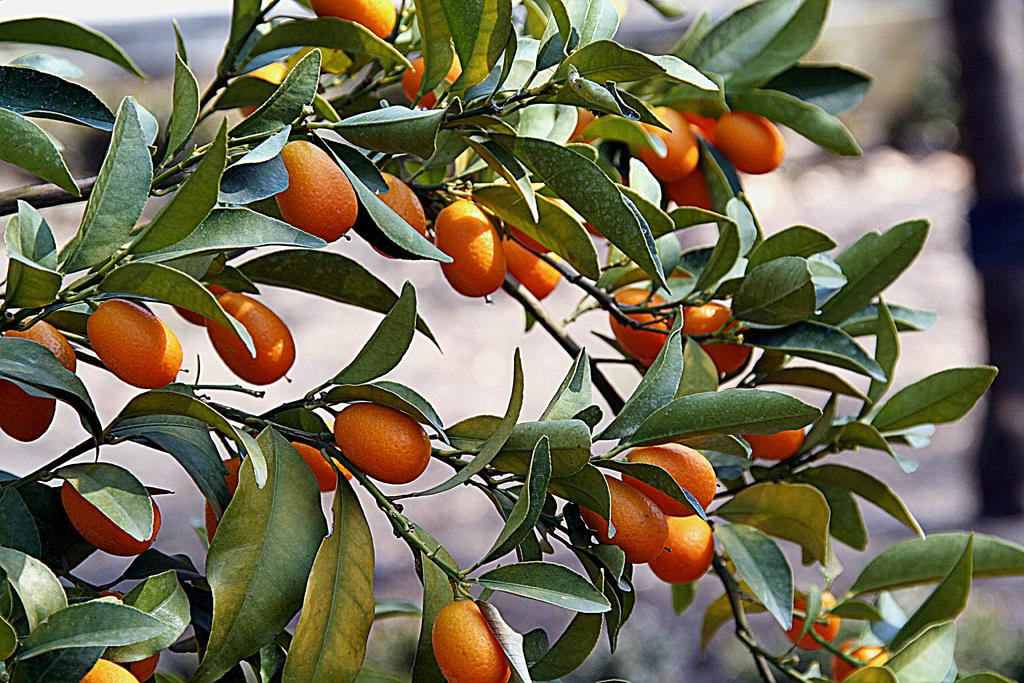What type of plant is in the image? There is a Kumquat plant in the image. Can you describe the background of the image? The background of the image is blurred. What is the temperature of the Kumquat plant in the image? The temperature of the Kumquat plant cannot be determined from the image alone, as it does not provide any information about the temperature. 